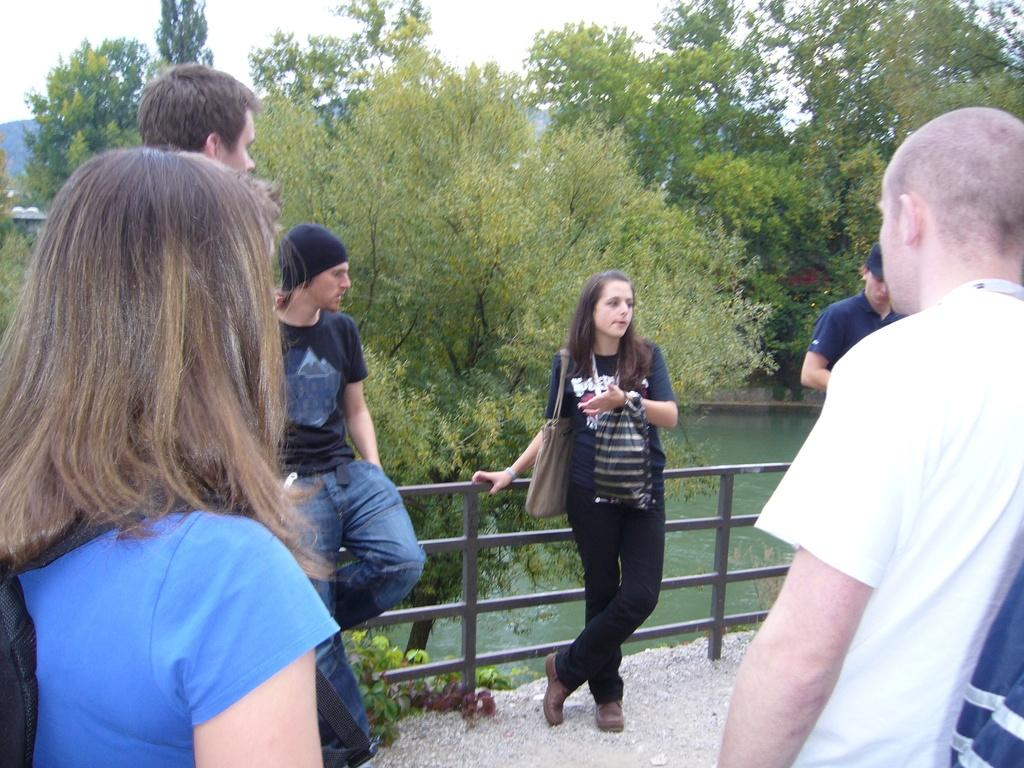What are the people in the image doing? There is a group of people standing on a path in the image. What can be seen near the people in the image? There is a fence in the image. What is visible in the background of the image? There are trees and water visible in the background of the image, as well as the sky. What type of wound can be seen on the person in the image? There is no person with a wound present in the image. What punishment is being given to the group of people in the image? There is no indication of punishment in the image; the group of people is simply standing on a path. 